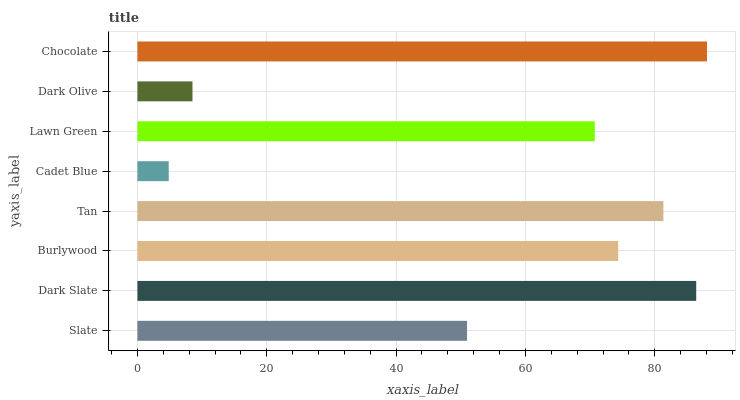Is Cadet Blue the minimum?
Answer yes or no. Yes. Is Chocolate the maximum?
Answer yes or no. Yes. Is Dark Slate the minimum?
Answer yes or no. No. Is Dark Slate the maximum?
Answer yes or no. No. Is Dark Slate greater than Slate?
Answer yes or no. Yes. Is Slate less than Dark Slate?
Answer yes or no. Yes. Is Slate greater than Dark Slate?
Answer yes or no. No. Is Dark Slate less than Slate?
Answer yes or no. No. Is Burlywood the high median?
Answer yes or no. Yes. Is Lawn Green the low median?
Answer yes or no. Yes. Is Dark Olive the high median?
Answer yes or no. No. Is Slate the low median?
Answer yes or no. No. 